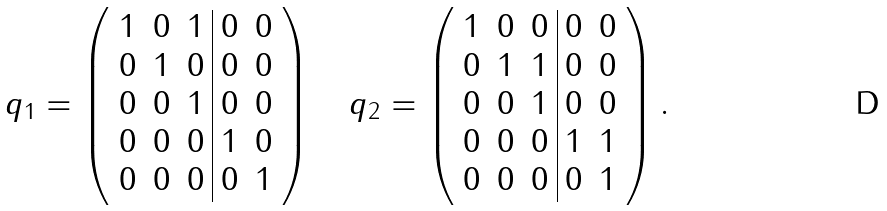<formula> <loc_0><loc_0><loc_500><loc_500>q _ { 1 } = \left ( \begin{array} { c c c | c c } 1 & 0 & 1 & 0 & 0 \\ 0 & 1 & 0 & 0 & 0 \\ 0 & 0 & 1 & 0 & 0 \\ 0 & 0 & 0 & 1 & 0 \\ 0 & 0 & 0 & 0 & 1 \end{array} \right ) \quad q _ { 2 } = \left ( \begin{array} { c c c | c c } 1 & 0 & 0 & 0 & 0 \\ 0 & 1 & 1 & 0 & 0 \\ 0 & 0 & 1 & 0 & 0 \\ 0 & 0 & 0 & 1 & 1 \\ 0 & 0 & 0 & 0 & 1 \end{array} \right ) .</formula> 